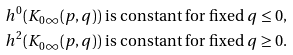<formula> <loc_0><loc_0><loc_500><loc_500>& h ^ { 0 } ( K _ { 0 \infty } ( p , q ) ) \text { is constant for fixed } q \leq 0 , \\ & h ^ { 2 } ( K _ { 0 \infty } ( p , q ) ) \text { is constant for fixed } q \geq 0 .</formula> 